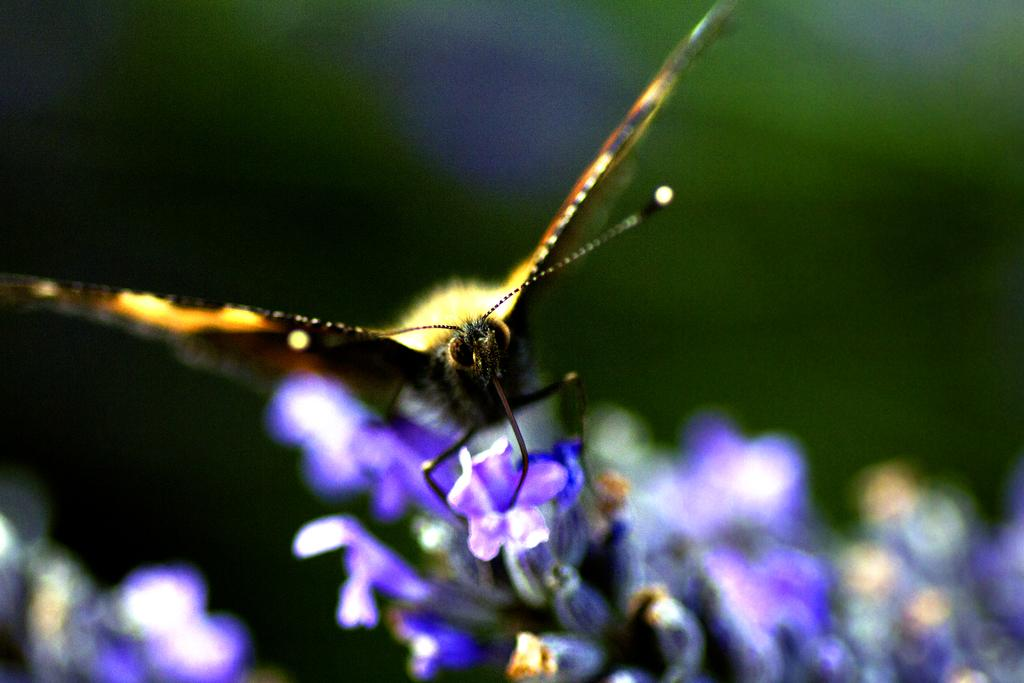What is the main subject of the image? The main subject of the image is a butterfly. Where is the butterfly located in the image? The butterfly is sitting on a group of flowers. What type of frame is surrounding the butterfly in the image? There is no frame surrounding the butterfly in the image; it is sitting on a group of flowers. How many legs can be seen on the butterfly in the image? Butterflies have six legs, but the image only shows the butterfly's body and wings, so it is not possible to count the legs from the image. 